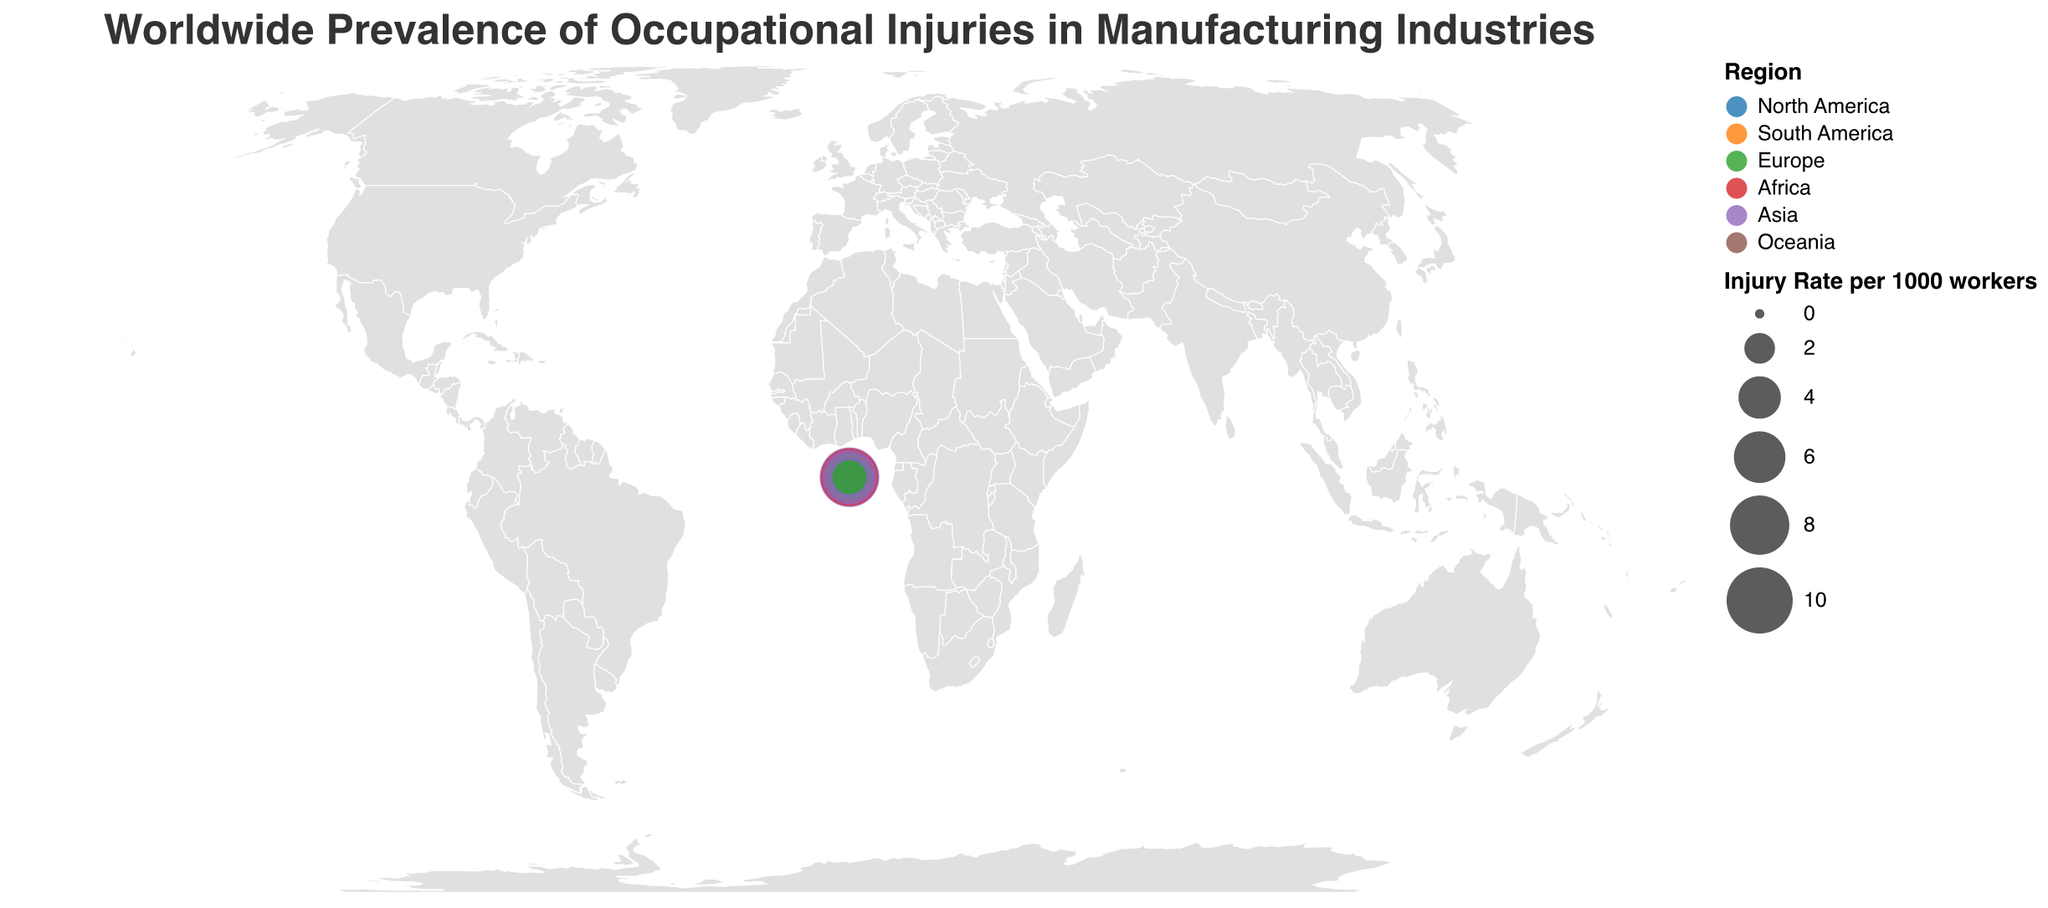What region has the highest injury rate per 1000 workers? The regions are color-coded in the plot, and the bubbles' sizes correspond to injury rates. The largest circle falls in Asia, specifically for India.
Answer: Asia Which country in Europe has the lowest injury rate per 1000 workers? Looking at the plot, the smallest circles in Europe represent the countries with the lowest injury rates. The country with the smallest circle in Europe is the United Kingdom.
Answer: United Kingdom What is the most common injury type in North America? By checking the tooltip information for countries in North America (United States, Mexico, Canada), the most common injury types are Musculoskeletal disorders, Chemical exposure, and Eye injuries.
Answer: Mixed (Musculoskeletal disorders, Chemical exposure, Eye injuries) What is the total injury rate per 1000 workers for countries in Europe? Sum the injury rates for Germany (2.8), United Kingdom (2.3), Russia (5.2), Italy (2.6), and France (2.5). The calculation is: 2.8 + 2.3 + 5.2 + 2.6 + 2.5 = 15.4.
Answer: 15.4 Which two countries have similar injury types in different regions? In North America, Mexico predominantly has Chemical exposure injuries. A similar type of injury which is specified in another region is not present. The closest similar injury type to Chemical exposure is related to respiratory problems in Indonesia from Asia.
Answer: No exact matches Which region shows greater variability in injury rates: Europe or Asia? Compare circles' sizes in Europe (2.3 to 5.2) and Asia (1.9 to 8.1). The disparity in injury rates in Asia is from 1.9 to 8.1, whereas in Europe, it's from 2.3 to 5.2.
Answer: Asia What is the common injury type in countries with an injury rate higher than 5.0 per 1000 workers? Identify countries with injury rates higher than 5.0 (China, Brazil, India, South Africa, Russia, Indonesia). Their injury types are Cuts and lacerations, Falls from height, Machine-related injuries, Crushing injuries, Fractures, and Respiratory problems.
Answer: Mixed (various injury types) In which country are workers more likely to suffer from machine-related injuries? Based on the most common injury type listed in the tooltip for each country, India shows that Machine-related injuries are the most common.
Answer: India Which country in Oceania is represented on the plot, and what is its injury rate? Based on the plot, the only country in Oceania shown is Australia. The injury rate per 1000 workers for Australia is given in the tooltip.
Answer: Australia: 3.9 